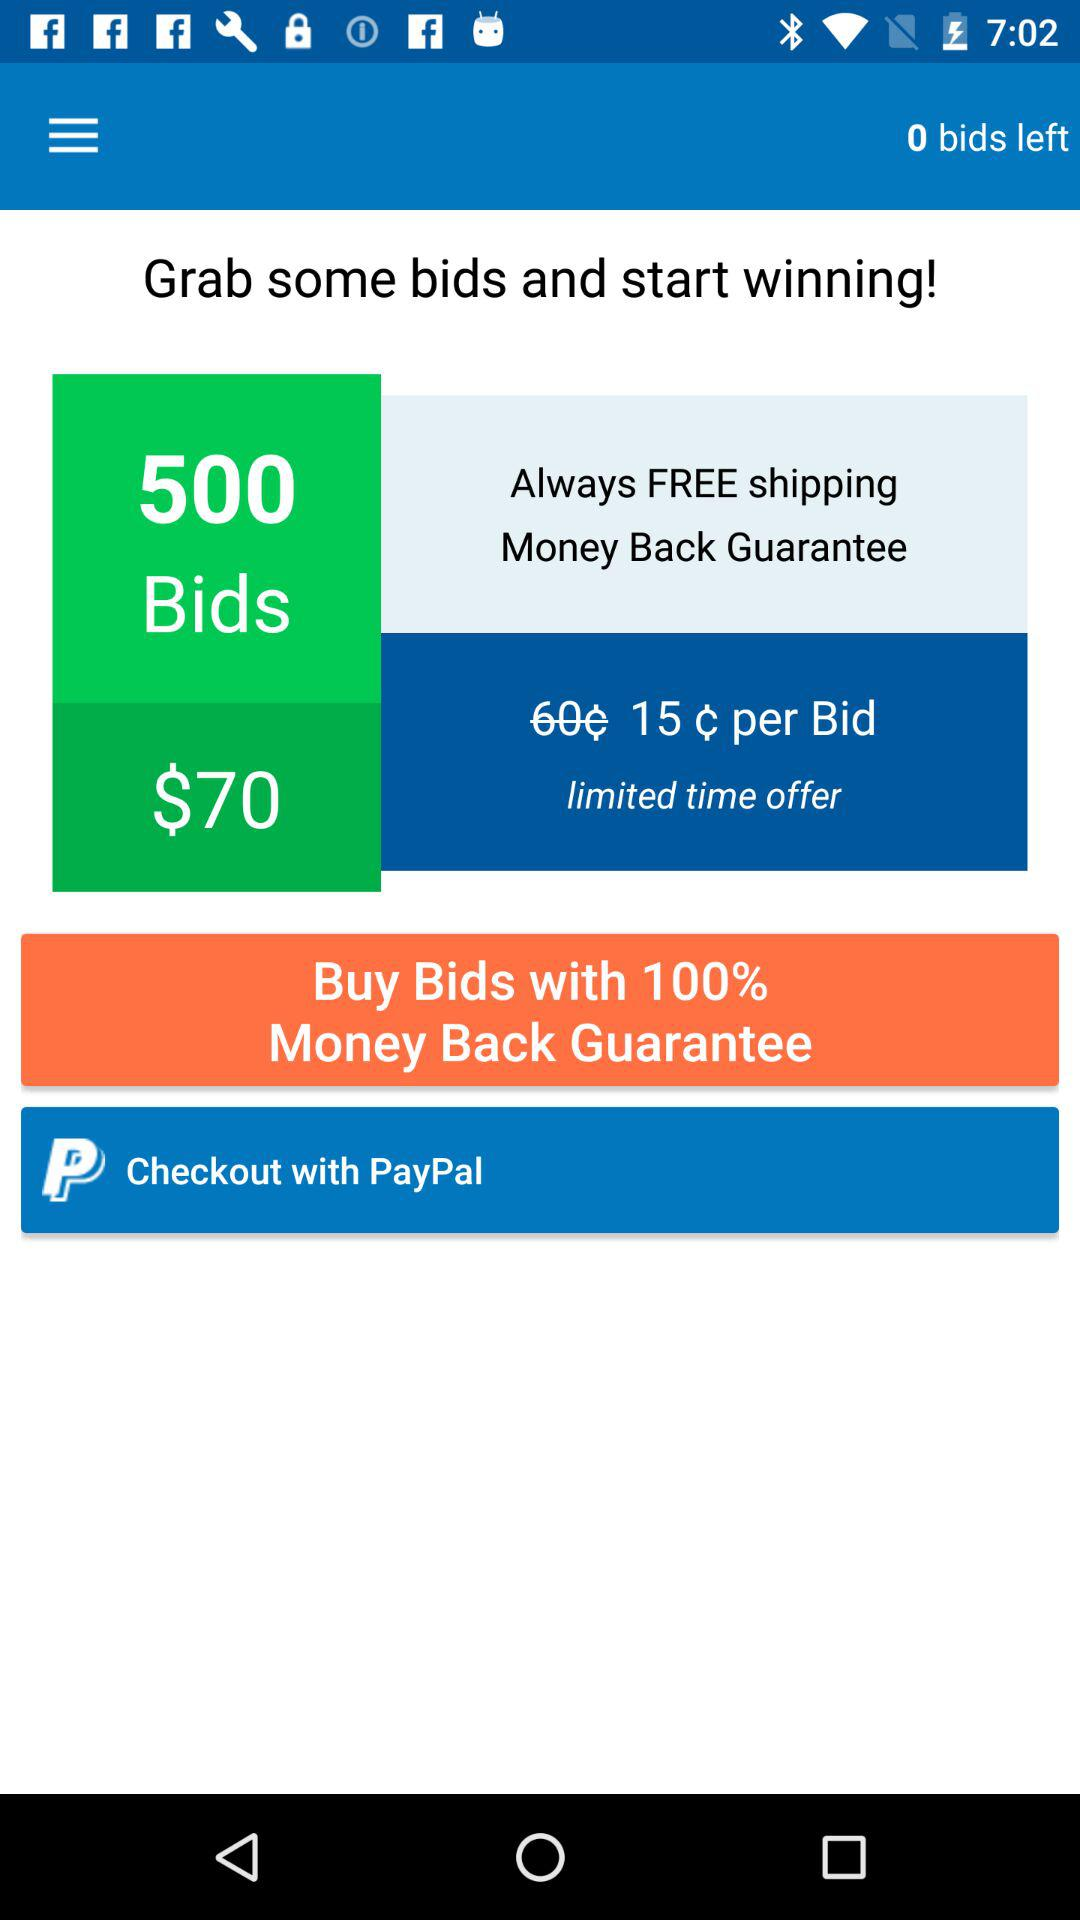What is the price of 500 bids? The price of 500 bids is $70. 